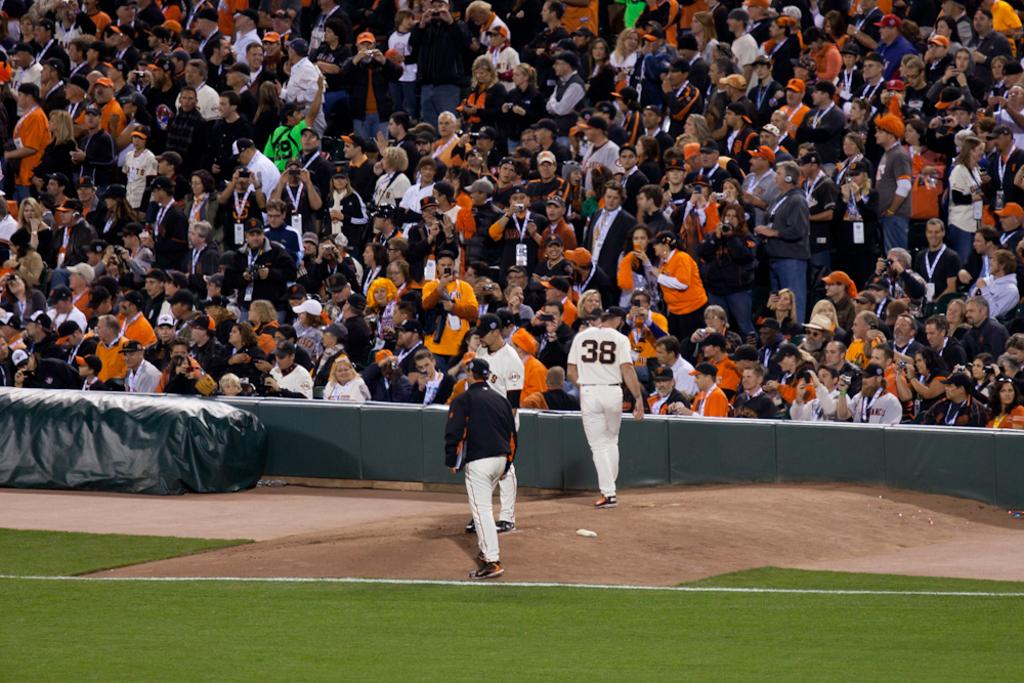<image>
Give a short and clear explanation of the subsequent image. Three baseball players on the field with on wearing a number 38 jersey. 